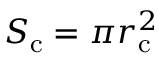Convert formula to latex. <formula><loc_0><loc_0><loc_500><loc_500>S _ { c } = \pi r _ { c } ^ { 2 }</formula> 